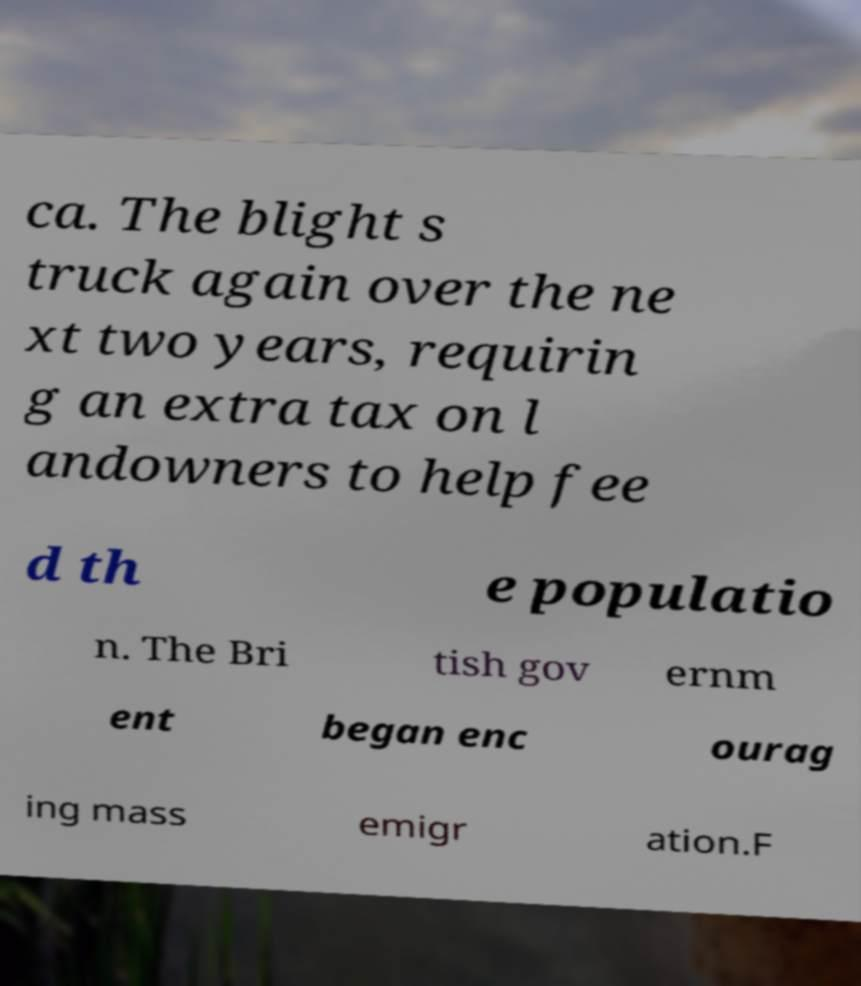Could you assist in decoding the text presented in this image and type it out clearly? ca. The blight s truck again over the ne xt two years, requirin g an extra tax on l andowners to help fee d th e populatio n. The Bri tish gov ernm ent began enc ourag ing mass emigr ation.F 